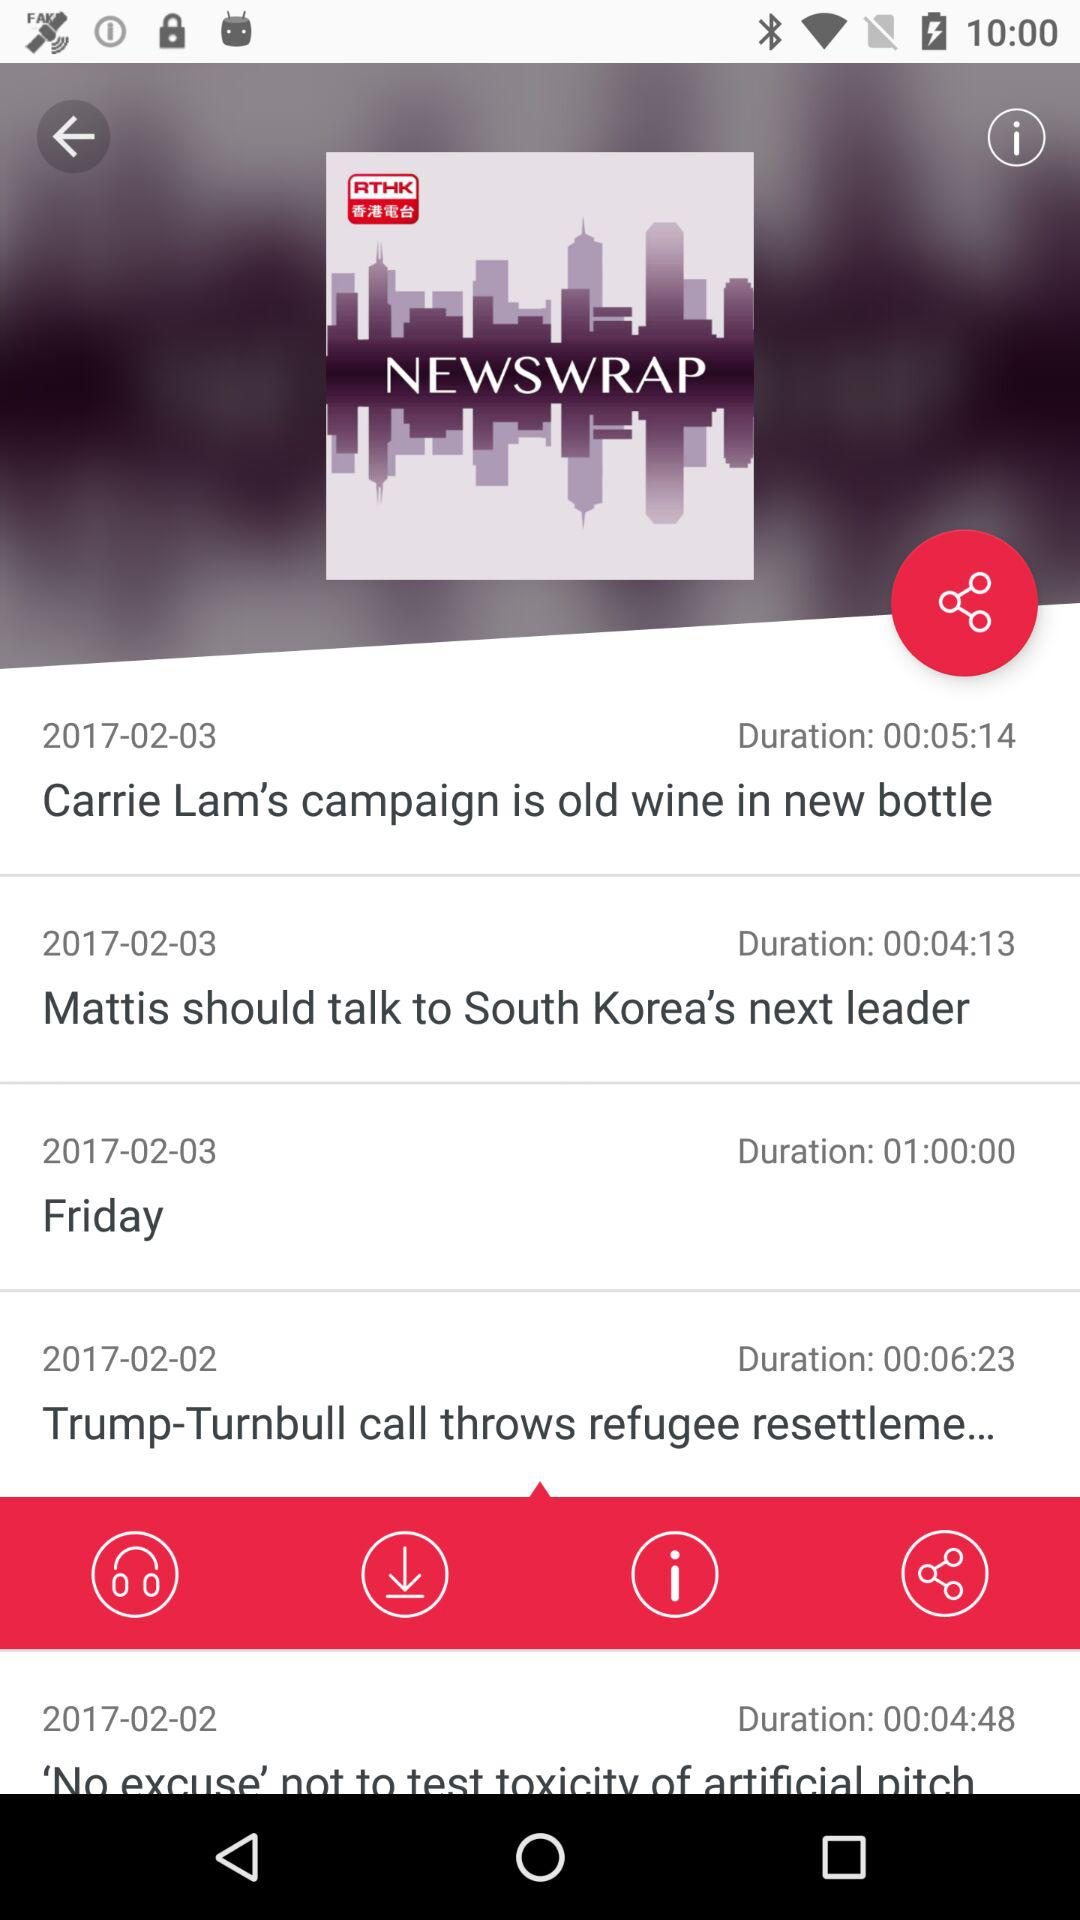What is the duration of the news that "Carrie Lam's campaign is old wine in a new bottle"? The duration of the news that "Carrie Lam's campaign is old wine in a new bottle" is 5 minutes 14 seconds. 